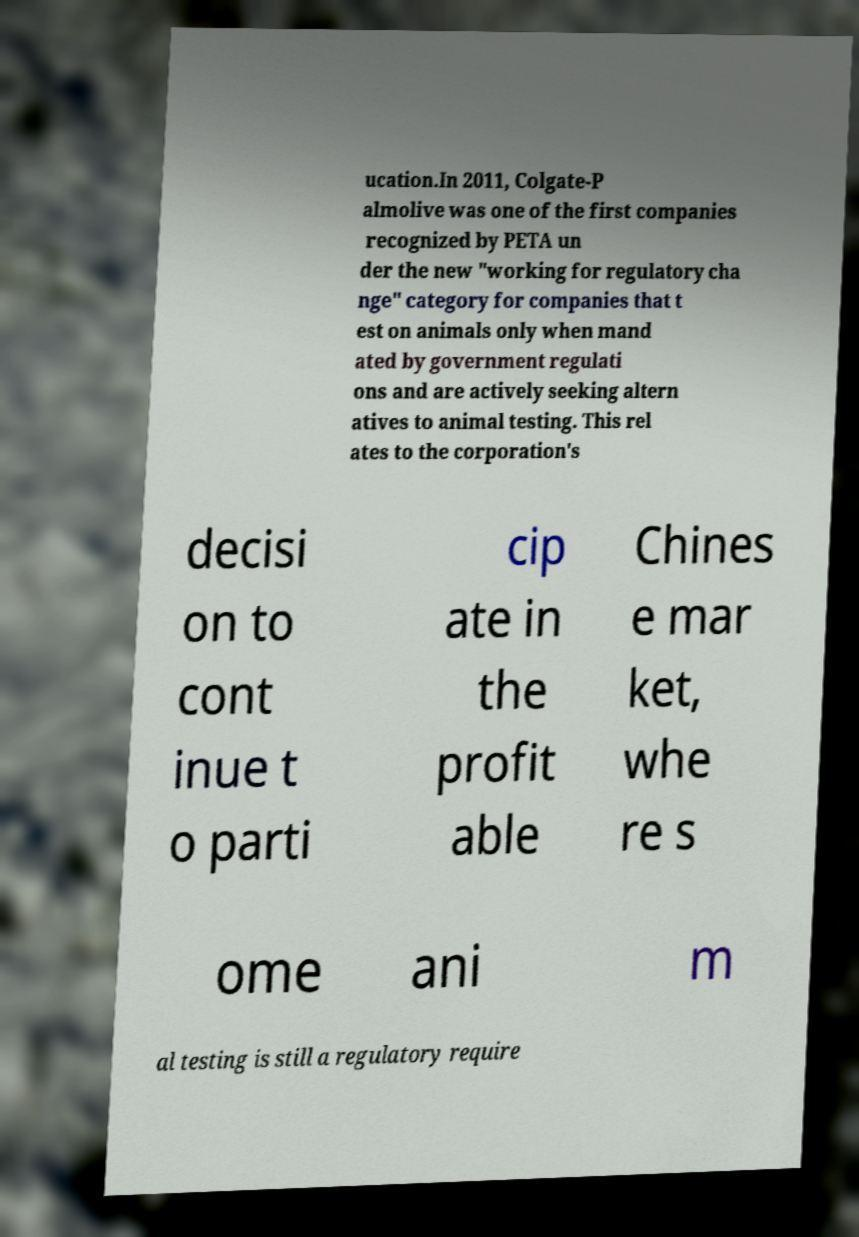What messages or text are displayed in this image? I need them in a readable, typed format. ucation.In 2011, Colgate-P almolive was one of the first companies recognized by PETA un der the new "working for regulatory cha nge" category for companies that t est on animals only when mand ated by government regulati ons and are actively seeking altern atives to animal testing. This rel ates to the corporation's decisi on to cont inue t o parti cip ate in the profit able Chines e mar ket, whe re s ome ani m al testing is still a regulatory require 